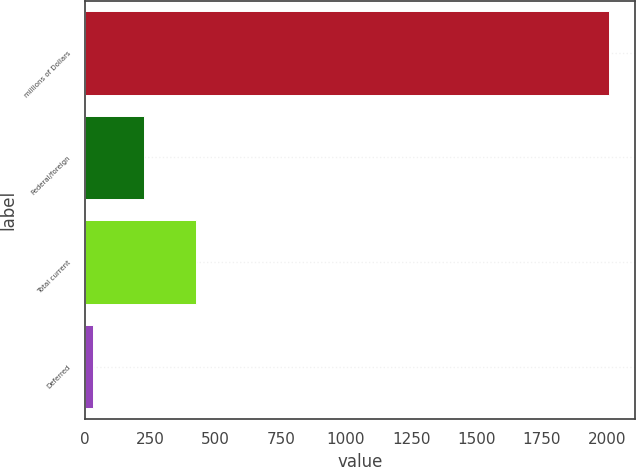Convert chart to OTSL. <chart><loc_0><loc_0><loc_500><loc_500><bar_chart><fcel>millions of Dollars<fcel>Federal/foreign<fcel>Total current<fcel>Deferred<nl><fcel>2008<fcel>227.98<fcel>425.76<fcel>30.2<nl></chart> 